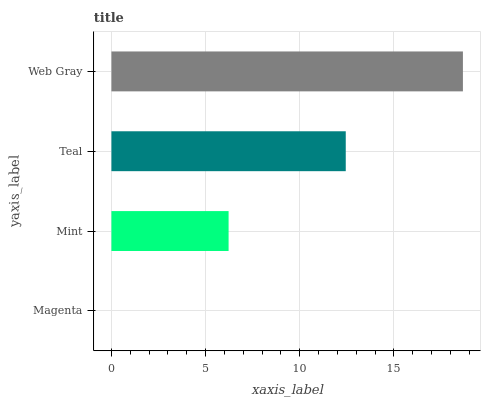Is Magenta the minimum?
Answer yes or no. Yes. Is Web Gray the maximum?
Answer yes or no. Yes. Is Mint the minimum?
Answer yes or no. No. Is Mint the maximum?
Answer yes or no. No. Is Mint greater than Magenta?
Answer yes or no. Yes. Is Magenta less than Mint?
Answer yes or no. Yes. Is Magenta greater than Mint?
Answer yes or no. No. Is Mint less than Magenta?
Answer yes or no. No. Is Teal the high median?
Answer yes or no. Yes. Is Mint the low median?
Answer yes or no. Yes. Is Magenta the high median?
Answer yes or no. No. Is Teal the low median?
Answer yes or no. No. 